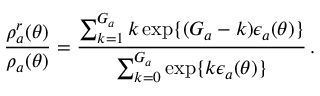<formula> <loc_0><loc_0><loc_500><loc_500>\frac { \rho _ { a } ^ { r } ( \theta ) } { \rho _ { a } ( \theta ) } = \frac { \sum _ { k = 1 } ^ { G _ { a } } k \exp \{ ( G _ { a } - k ) \epsilon _ { a } ( \theta ) \} } { \sum _ { k = 0 } ^ { G _ { a } } \exp \{ k \epsilon _ { a } ( \theta ) \} } \, .</formula> 